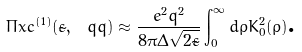Convert formula to latex. <formula><loc_0><loc_0><loc_500><loc_500>\Pi x c ^ { ( 1 ) } ( \tilde { \varepsilon } , \ q q ) \approx \frac { e ^ { 2 } q ^ { 2 } } { 8 \pi \Delta \sqrt { 2 \tilde { \varepsilon } } } \int _ { 0 } ^ { \infty } d \rho K _ { 0 } ^ { 2 } ( \rho ) \text {.}</formula> 